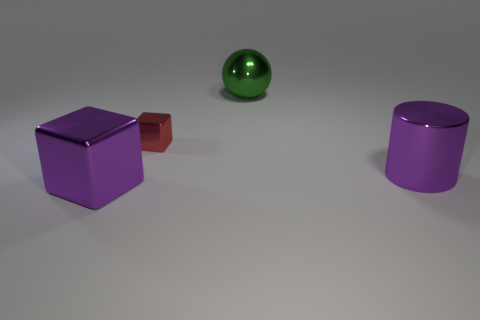What number of other objects are there of the same material as the purple cube? In the image, there is a total of one other object made of the same glossy material as the purple cube, which is the purple cylinder. 